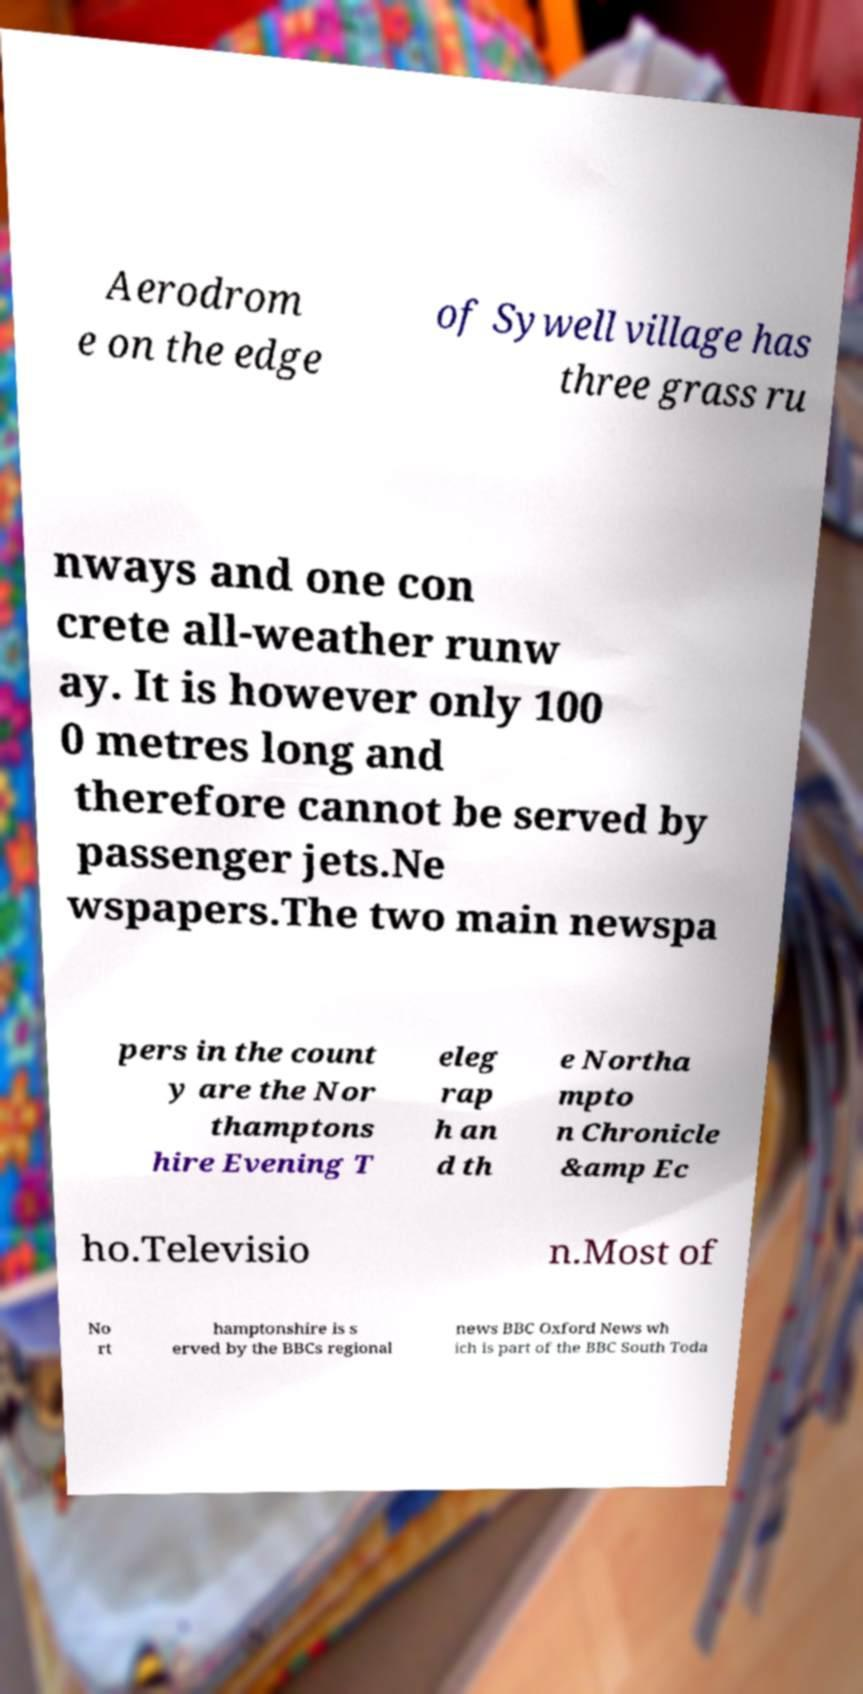Can you read and provide the text displayed in the image?This photo seems to have some interesting text. Can you extract and type it out for me? Aerodrom e on the edge of Sywell village has three grass ru nways and one con crete all-weather runw ay. It is however only 100 0 metres long and therefore cannot be served by passenger jets.Ne wspapers.The two main newspa pers in the count y are the Nor thamptons hire Evening T eleg rap h an d th e Northa mpto n Chronicle &amp Ec ho.Televisio n.Most of No rt hamptonshire is s erved by the BBCs regional news BBC Oxford News wh ich is part of the BBC South Toda 